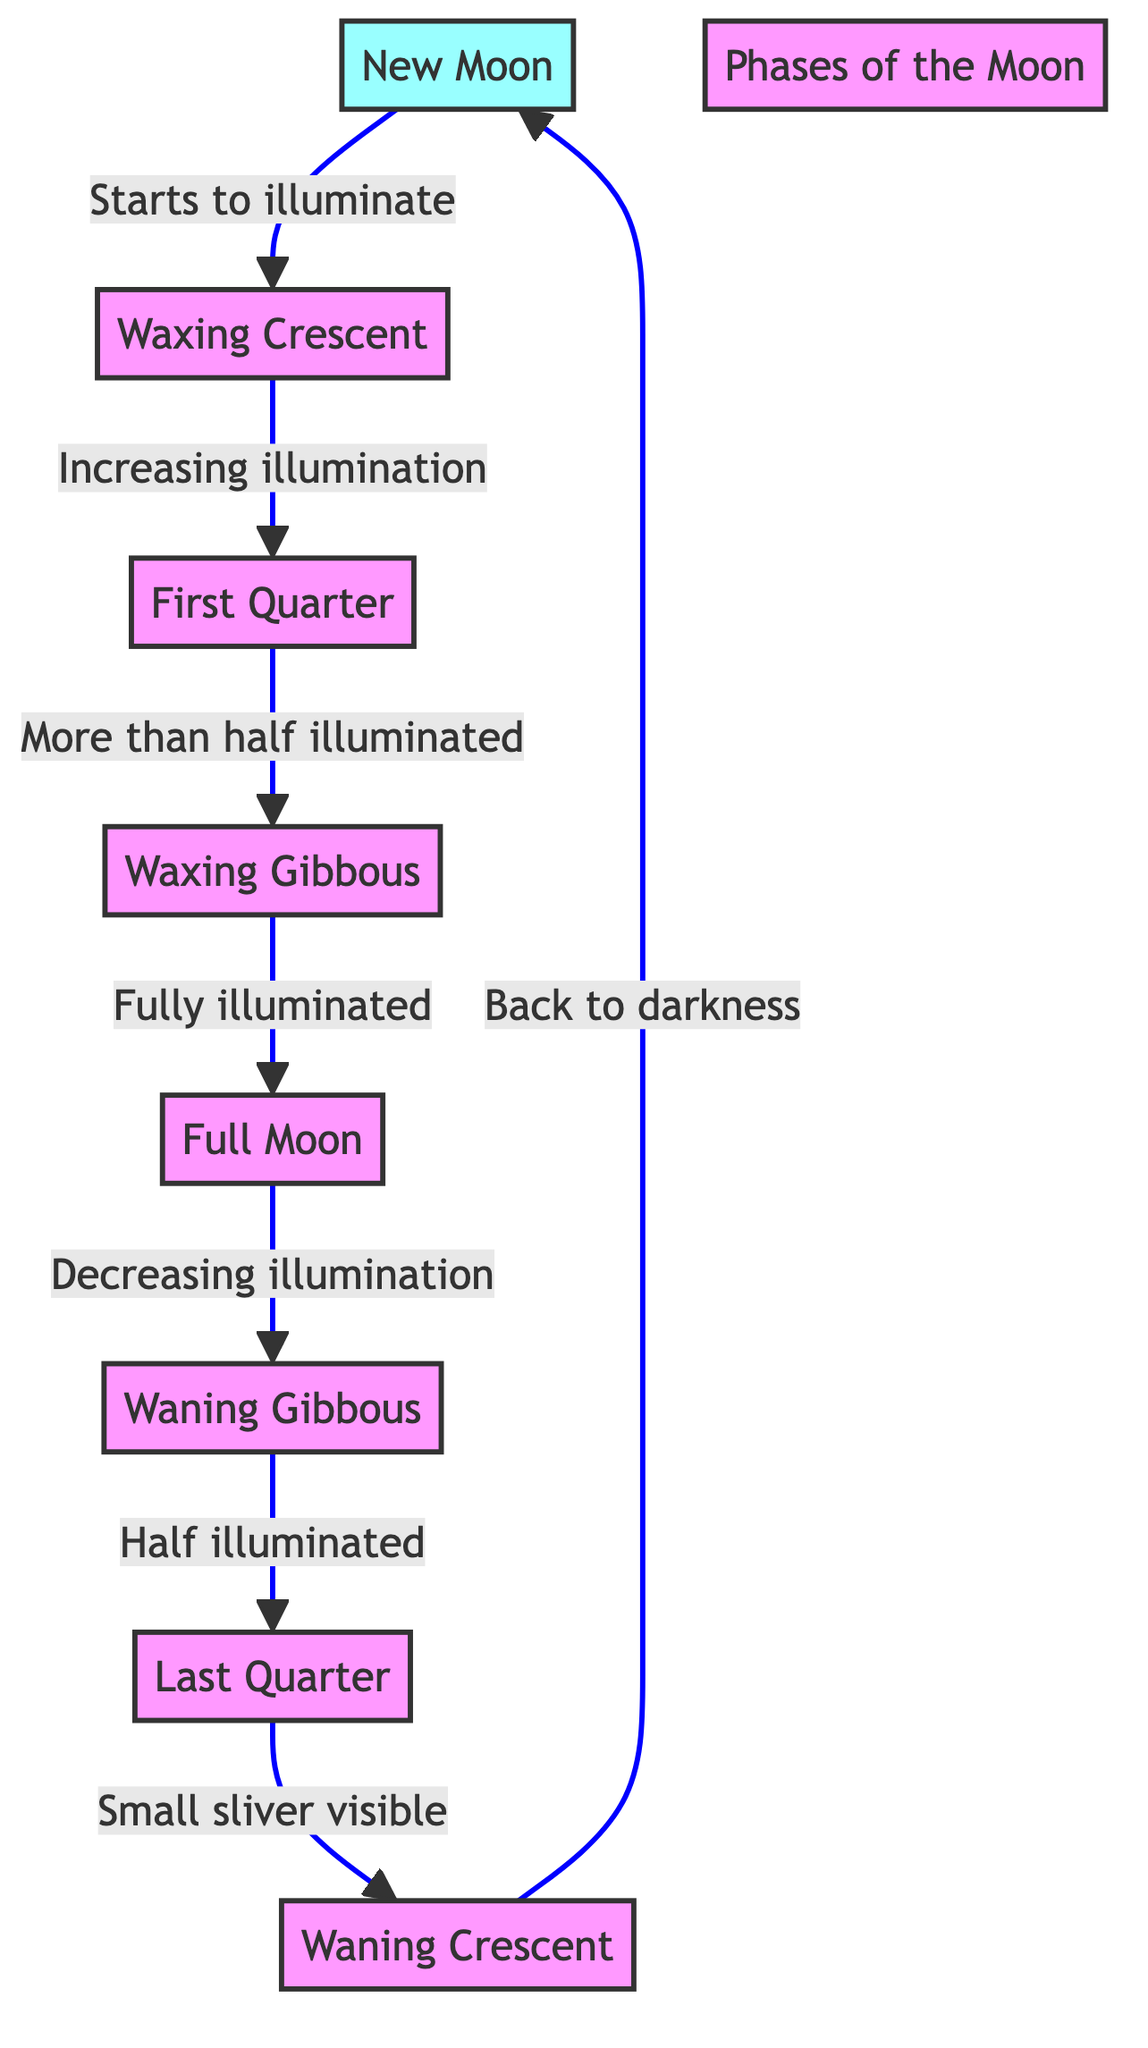What is the first phase of the moon depicted in the diagram? The diagram starts at the New Moon (NM) phase, which is the first node in the sequence. This is visually apparent as it is labeled as the starting point.
Answer: New Moon How many total phases of the moon are illustrated in the diagram? By counting the nodes, which include New Moon, Waxing Crescent, First Quarter, Waxing Gibbous, Full Moon, Waning Gibbous, Last Quarter, and Waning Crescent, there are a total of 8 distinct phases shown.
Answer: 8 What follows the Full Moon phase? The flow from the Full Moon (FM) phase leads to the Waning Gibbous (WNG) phase, as indicated by the arrow pointing from FM to WNG. This shows the progression after reaching full illumination.
Answer: Waning Gibbous Which phase has a small sliver visible? The diagram states that the Last Quarter (LQ) phase features a small sliver of illumination visible, as this is the label associated with that specific phase.
Answer: Last Quarter What is the relationship between the Waxing Gibbous and the Full Moon phases? The diagram illustrates that Waxing Gibbous (WXG) leads directly to Full Moon (FM) and indicates that the Waxing Gibbous phase is the stage just before the Full Moon, showing an increasing pattern of illumination.
Answer: WXG to FM Which phases show decreasing illumination? The diagram depicts that both the Full Moon (FM) phase and the Waning Gibbous (WNG) phase are connected to decreasing illumination as each transitions to the next phase. This is indicated by the labeled arrows that describe the change.
Answer: Full Moon and Waning Gibbous What happens after the New Moon phase? Following the New Moon (NM) phase, the diagram indicates that it transitions to the Waxing Crescent (WXC) phase, demonstrating the start of illumination after darkness.
Answer: Waxing Crescent Which phase represents more than half illuminated? The diagram clearly states that the First Quarter (FQ) phase is when the moon is more than half illuminated as it progresses to the Waxing Gibbous phase next.
Answer: First Quarter 